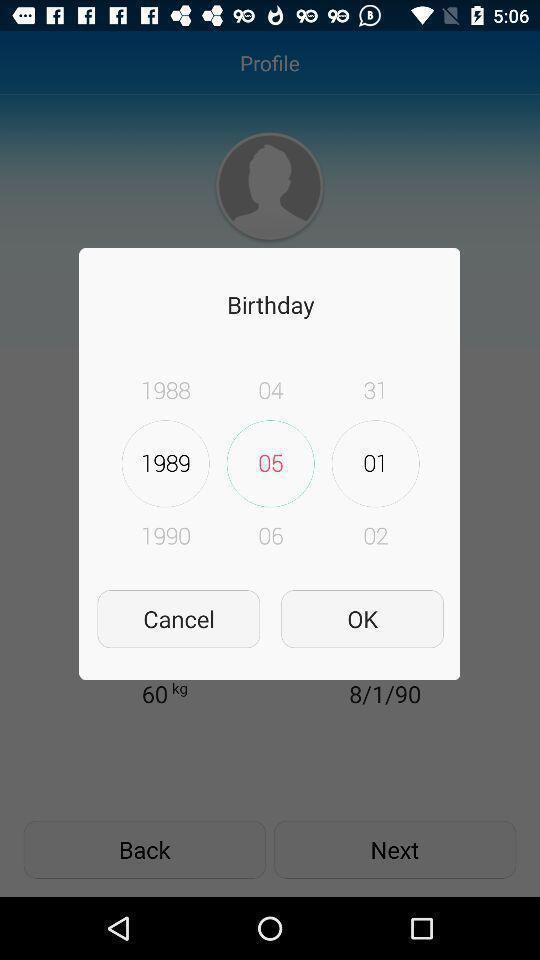Explain what's happening in this screen capture. Pop-up showing the birthday of a profile. 